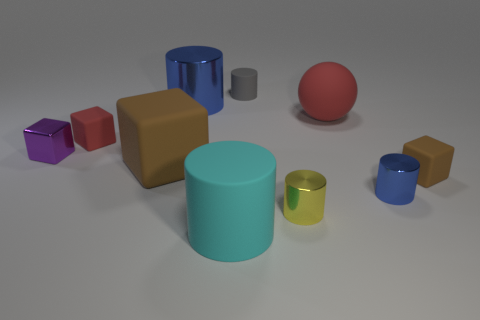Subtract all cyan cylinders. How many cylinders are left? 4 Subtract all gray cylinders. How many cylinders are left? 4 Subtract all spheres. How many objects are left? 9 Subtract 4 cylinders. How many cylinders are left? 1 Subtract all green spheres. How many blue cylinders are left? 2 Subtract all big matte cylinders. Subtract all metal cubes. How many objects are left? 8 Add 2 purple cubes. How many purple cubes are left? 3 Add 7 tiny brown matte cubes. How many tiny brown matte cubes exist? 8 Subtract 1 yellow cylinders. How many objects are left? 9 Subtract all blue cylinders. Subtract all red spheres. How many cylinders are left? 3 